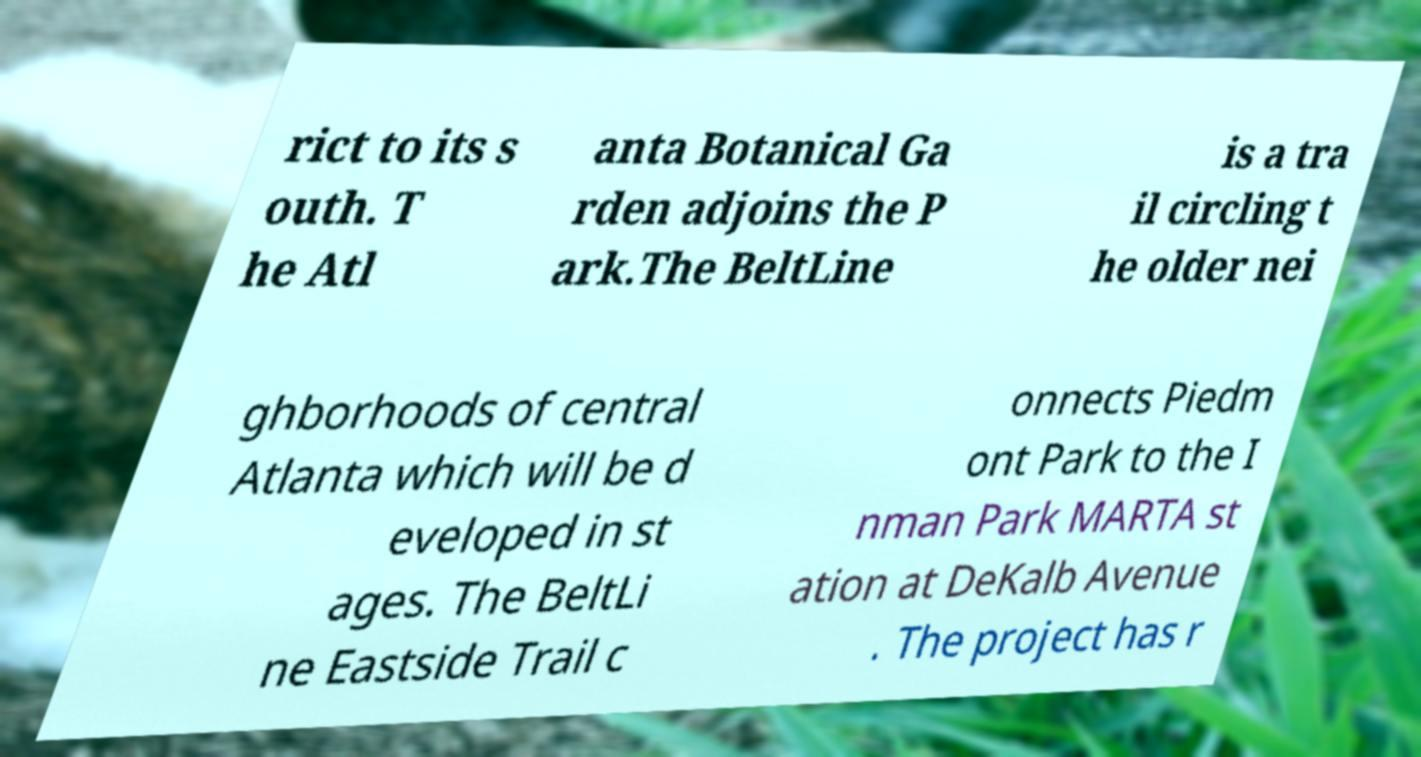Please read and relay the text visible in this image. What does it say? rict to its s outh. T he Atl anta Botanical Ga rden adjoins the P ark.The BeltLine is a tra il circling t he older nei ghborhoods of central Atlanta which will be d eveloped in st ages. The BeltLi ne Eastside Trail c onnects Piedm ont Park to the I nman Park MARTA st ation at DeKalb Avenue . The project has r 